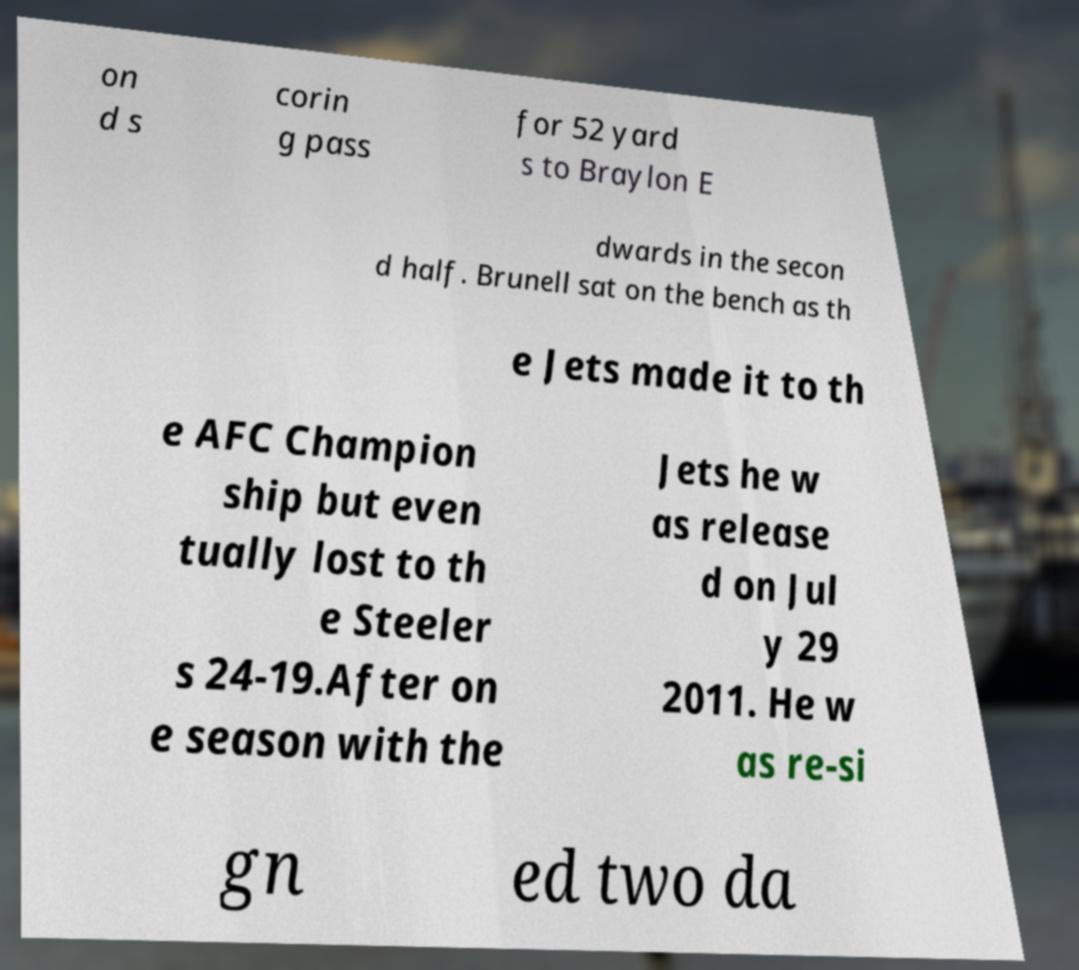There's text embedded in this image that I need extracted. Can you transcribe it verbatim? on d s corin g pass for 52 yard s to Braylon E dwards in the secon d half. Brunell sat on the bench as th e Jets made it to th e AFC Champion ship but even tually lost to th e Steeler s 24-19.After on e season with the Jets he w as release d on Jul y 29 2011. He w as re-si gn ed two da 